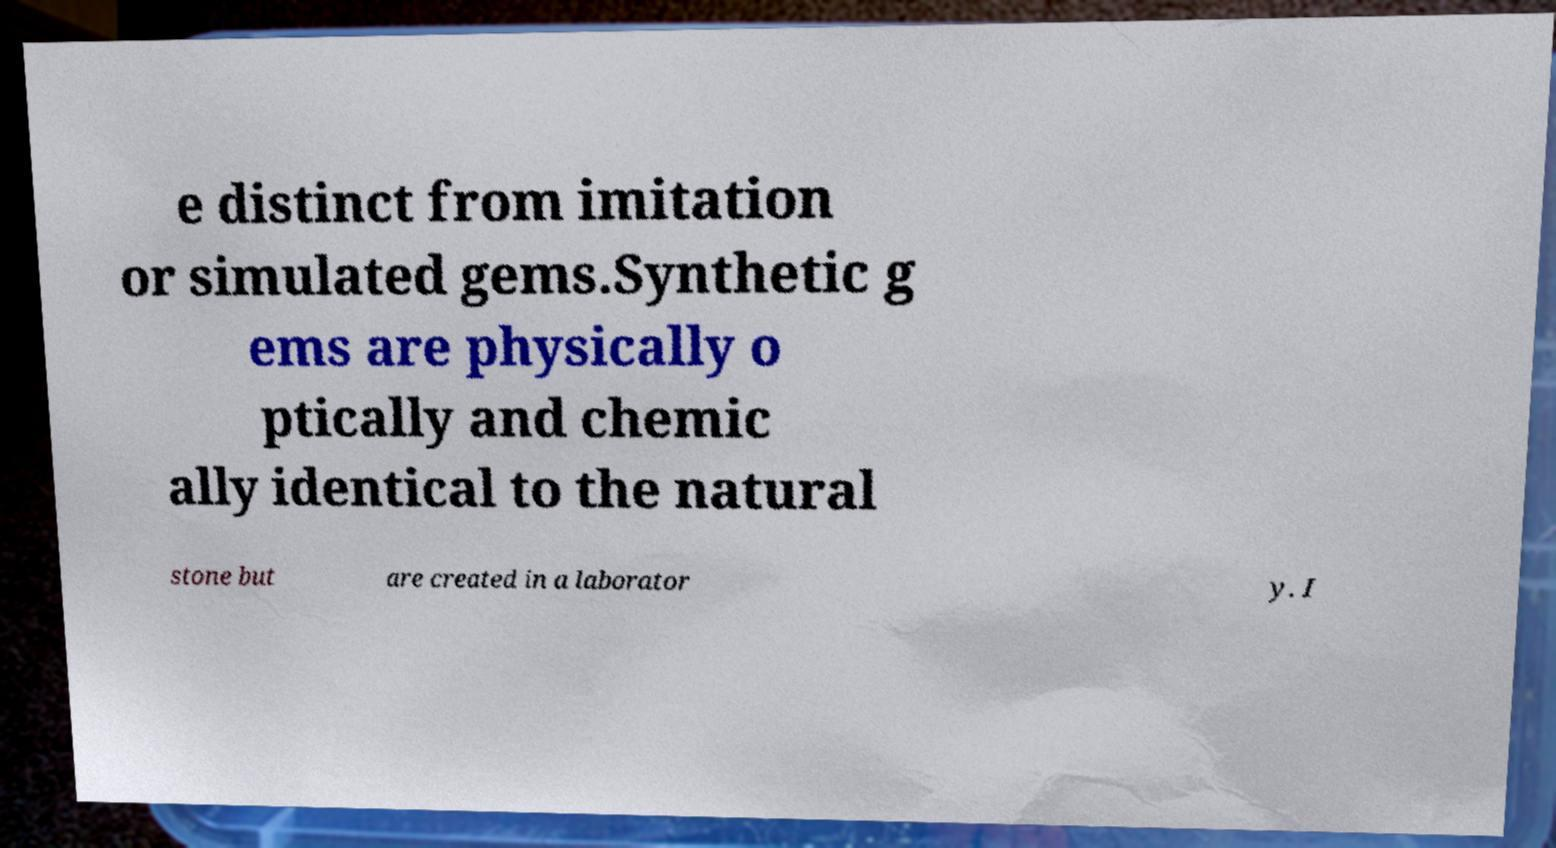For documentation purposes, I need the text within this image transcribed. Could you provide that? e distinct from imitation or simulated gems.Synthetic g ems are physically o ptically and chemic ally identical to the natural stone but are created in a laborator y. I 